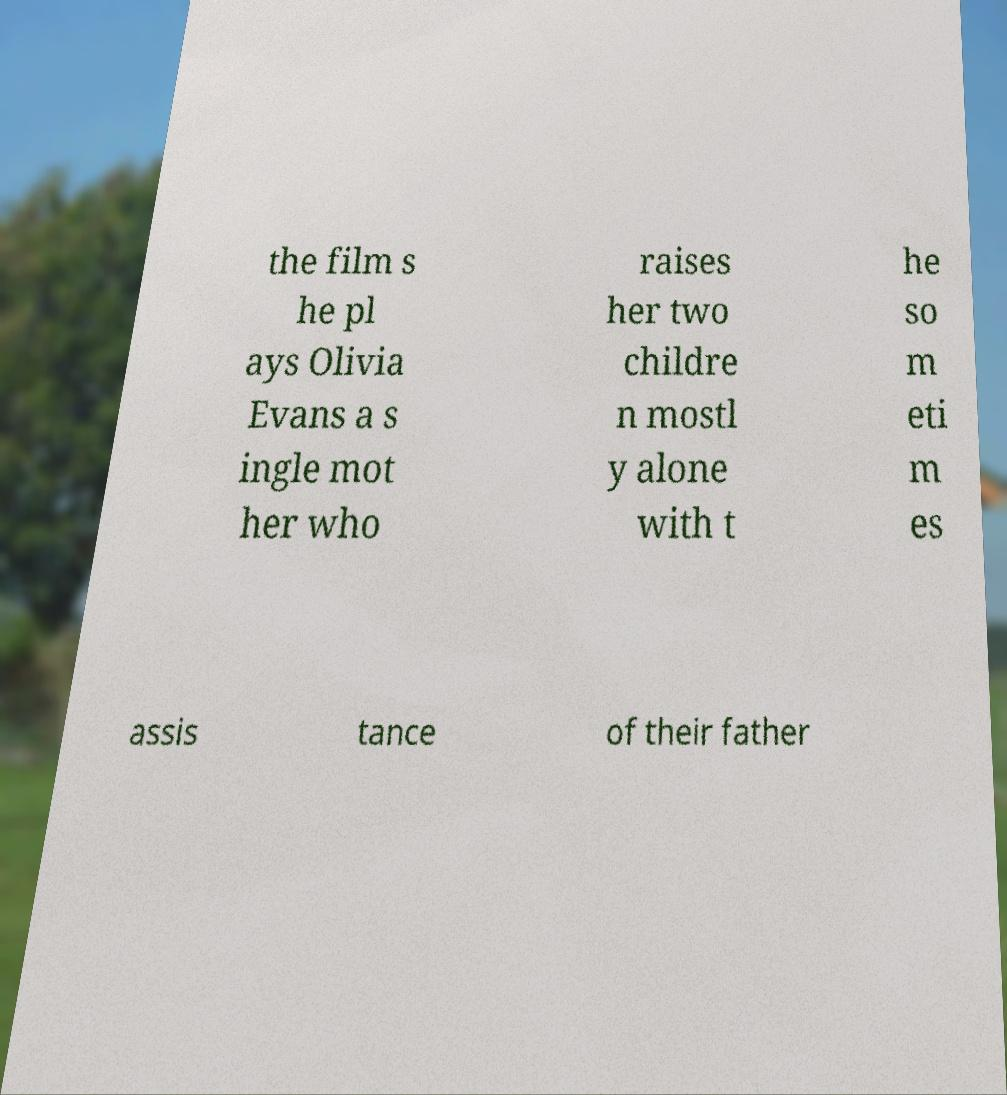Could you assist in decoding the text presented in this image and type it out clearly? the film s he pl ays Olivia Evans a s ingle mot her who raises her two childre n mostl y alone with t he so m eti m es assis tance of their father 